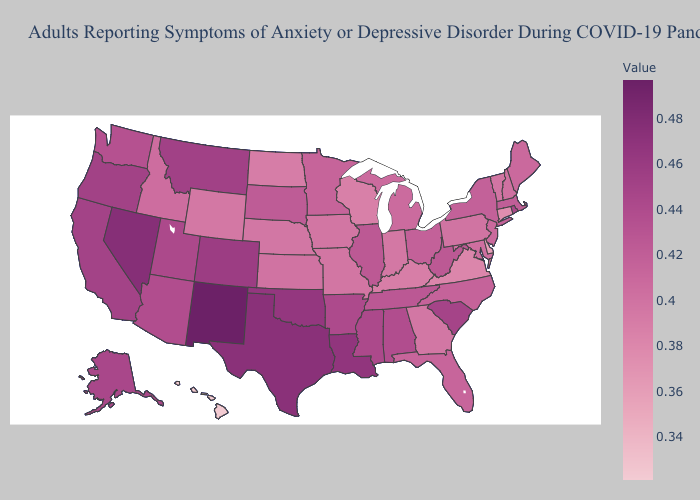Does Hawaii have the lowest value in the USA?
Quick response, please. Yes. Which states have the highest value in the USA?
Concise answer only. New Mexico. Does Connecticut have the lowest value in the Northeast?
Quick response, please. Yes. Which states have the lowest value in the South?
Be succinct. Delaware. Does Rhode Island have the highest value in the USA?
Concise answer only. No. Does Tennessee have a higher value than Wyoming?
Keep it brief. Yes. Does Oklahoma have a higher value than Idaho?
Answer briefly. Yes. Which states have the lowest value in the USA?
Give a very brief answer. Hawaii. 